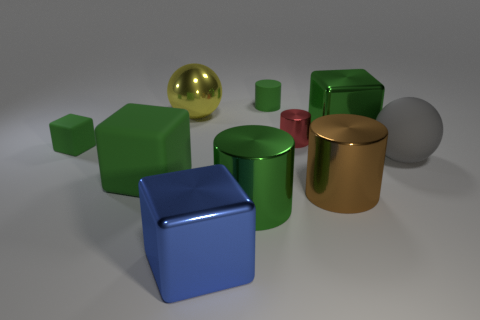There is a rubber cylinder that is the same color as the small cube; what is its size?
Make the answer very short. Small. There is a rubber block in front of the tiny block; is it the same color as the small rubber cube?
Offer a terse response. Yes. There is a small cylinder that is the same color as the tiny cube; what is it made of?
Provide a succinct answer. Rubber. Is there a cylinder of the same color as the tiny cube?
Offer a very short reply. Yes. Are there an equal number of big green metallic cubes that are left of the big green metallic cylinder and tiny blue matte cylinders?
Offer a terse response. Yes. What number of yellow rubber things are the same shape as the blue thing?
Keep it short and to the point. 0. There is a red object that is in front of the big block on the right side of the tiny cylinder behind the red metal thing; how big is it?
Make the answer very short. Small. Are the sphere on the left side of the blue shiny object and the big green cylinder made of the same material?
Offer a terse response. Yes. Are there the same number of shiny balls on the right side of the blue shiny object and objects in front of the large green rubber object?
Provide a succinct answer. No. What material is the red thing that is the same shape as the brown metal thing?
Offer a terse response. Metal. 